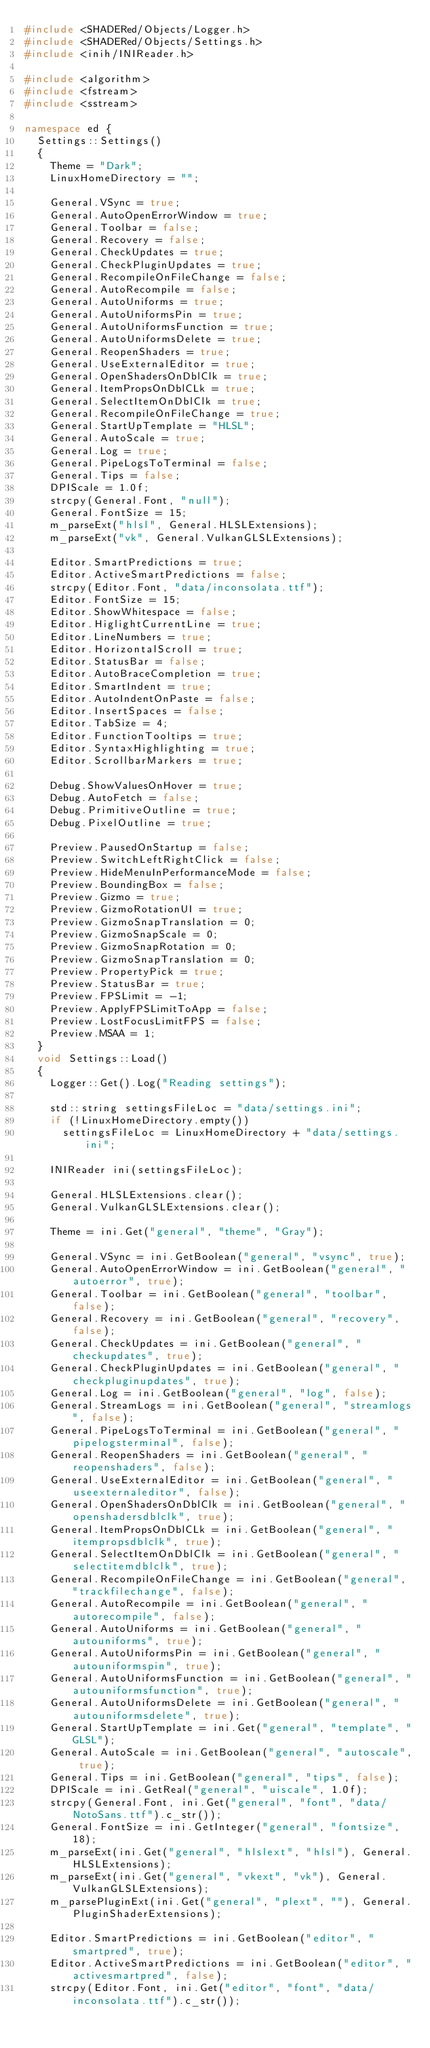Convert code to text. <code><loc_0><loc_0><loc_500><loc_500><_C++_>#include <SHADERed/Objects/Logger.h>
#include <SHADERed/Objects/Settings.h>
#include <inih/INIReader.h>

#include <algorithm>
#include <fstream>
#include <sstream>

namespace ed {
	Settings::Settings()
	{
		Theme = "Dark";
		LinuxHomeDirectory = "";

		General.VSync = true;
		General.AutoOpenErrorWindow = true;
		General.Toolbar = false;
		General.Recovery = false;
		General.CheckUpdates = true;
		General.CheckPluginUpdates = true;
		General.RecompileOnFileChange = false;
		General.AutoRecompile = false;
		General.AutoUniforms = true;
		General.AutoUniformsPin = true;
		General.AutoUniformsFunction = true;
		General.AutoUniformsDelete = true;
		General.ReopenShaders = true;
		General.UseExternalEditor = true;
		General.OpenShadersOnDblClk = true;
		General.ItemPropsOnDblCLk = true;
		General.SelectItemOnDblClk = true;
		General.RecompileOnFileChange = true;
		General.StartUpTemplate = "HLSL";
		General.AutoScale = true;
		General.Log = true;
		General.PipeLogsToTerminal = false;
		General.Tips = false;
		DPIScale = 1.0f;
		strcpy(General.Font, "null");
		General.FontSize = 15;
		m_parseExt("hlsl", General.HLSLExtensions);
		m_parseExt("vk", General.VulkanGLSLExtensions);

		Editor.SmartPredictions = true;
		Editor.ActiveSmartPredictions = false;
		strcpy(Editor.Font, "data/inconsolata.ttf");
		Editor.FontSize = 15;
		Editor.ShowWhitespace = false;
		Editor.HiglightCurrentLine = true;
		Editor.LineNumbers = true;
		Editor.HorizontalScroll = true;
		Editor.StatusBar = false;
		Editor.AutoBraceCompletion = true;
		Editor.SmartIndent = true;
		Editor.AutoIndentOnPaste = false;
		Editor.InsertSpaces = false;
		Editor.TabSize = 4;
		Editor.FunctionTooltips = true;
		Editor.SyntaxHighlighting = true;
		Editor.ScrollbarMarkers = true;

		Debug.ShowValuesOnHover = true;
		Debug.AutoFetch = false;
		Debug.PrimitiveOutline = true;
		Debug.PixelOutline = true;

		Preview.PausedOnStartup = false;
		Preview.SwitchLeftRightClick = false;
		Preview.HideMenuInPerformanceMode = false;
		Preview.BoundingBox = false;
		Preview.Gizmo = true;
		Preview.GizmoRotationUI = true;
		Preview.GizmoSnapTranslation = 0;
		Preview.GizmoSnapScale = 0;
		Preview.GizmoSnapRotation = 0;
		Preview.GizmoSnapTranslation = 0;
		Preview.PropertyPick = true;
		Preview.StatusBar = true;
		Preview.FPSLimit = -1;
		Preview.ApplyFPSLimitToApp = false;
		Preview.LostFocusLimitFPS = false;
		Preview.MSAA = 1;
	}
	void Settings::Load()
	{
		Logger::Get().Log("Reading settings");

		std::string settingsFileLoc = "data/settings.ini";
		if (!LinuxHomeDirectory.empty())
			settingsFileLoc = LinuxHomeDirectory + "data/settings.ini";
		
		INIReader ini(settingsFileLoc);

		General.HLSLExtensions.clear();
		General.VulkanGLSLExtensions.clear();

		Theme = ini.Get("general", "theme", "Gray");

		General.VSync = ini.GetBoolean("general", "vsync", true);
		General.AutoOpenErrorWindow = ini.GetBoolean("general", "autoerror", true);
		General.Toolbar = ini.GetBoolean("general", "toolbar", false);
		General.Recovery = ini.GetBoolean("general", "recovery", false);
		General.CheckUpdates = ini.GetBoolean("general", "checkupdates", true);
		General.CheckPluginUpdates = ini.GetBoolean("general", "checkpluginupdates", true);
		General.Log = ini.GetBoolean("general", "log", false);
		General.StreamLogs = ini.GetBoolean("general", "streamlogs", false);
		General.PipeLogsToTerminal = ini.GetBoolean("general", "pipelogsterminal", false);
		General.ReopenShaders = ini.GetBoolean("general", "reopenshaders", false);
		General.UseExternalEditor = ini.GetBoolean("general", "useexternaleditor", false);
		General.OpenShadersOnDblClk = ini.GetBoolean("general", "openshadersdblclk", true);
		General.ItemPropsOnDblCLk = ini.GetBoolean("general", "itempropsdblclk", true);
		General.SelectItemOnDblClk = ini.GetBoolean("general", "selectitemdblclk", true);
		General.RecompileOnFileChange = ini.GetBoolean("general", "trackfilechange", false);
		General.AutoRecompile = ini.GetBoolean("general", "autorecompile", false);
		General.AutoUniforms = ini.GetBoolean("general", "autouniforms", true);
		General.AutoUniformsPin = ini.GetBoolean("general", "autouniformspin", true);
		General.AutoUniformsFunction = ini.GetBoolean("general", "autouniformsfunction", true);
		General.AutoUniformsDelete = ini.GetBoolean("general", "autouniformsdelete", true);
		General.StartUpTemplate = ini.Get("general", "template", "GLSL");
		General.AutoScale = ini.GetBoolean("general", "autoscale", true);
		General.Tips = ini.GetBoolean("general", "tips", false);
		DPIScale = ini.GetReal("general", "uiscale", 1.0f);
		strcpy(General.Font, ini.Get("general", "font", "data/NotoSans.ttf").c_str());
		General.FontSize = ini.GetInteger("general", "fontsize", 18);
		m_parseExt(ini.Get("general", "hlslext", "hlsl"), General.HLSLExtensions);
		m_parseExt(ini.Get("general", "vkext", "vk"), General.VulkanGLSLExtensions);
		m_parsePluginExt(ini.Get("general", "plext", ""), General.PluginShaderExtensions);

		Editor.SmartPredictions = ini.GetBoolean("editor", "smartpred", true);
		Editor.ActiveSmartPredictions = ini.GetBoolean("editor", "activesmartpred", false);
		strcpy(Editor.Font, ini.Get("editor", "font", "data/inconsolata.ttf").c_str());</code> 